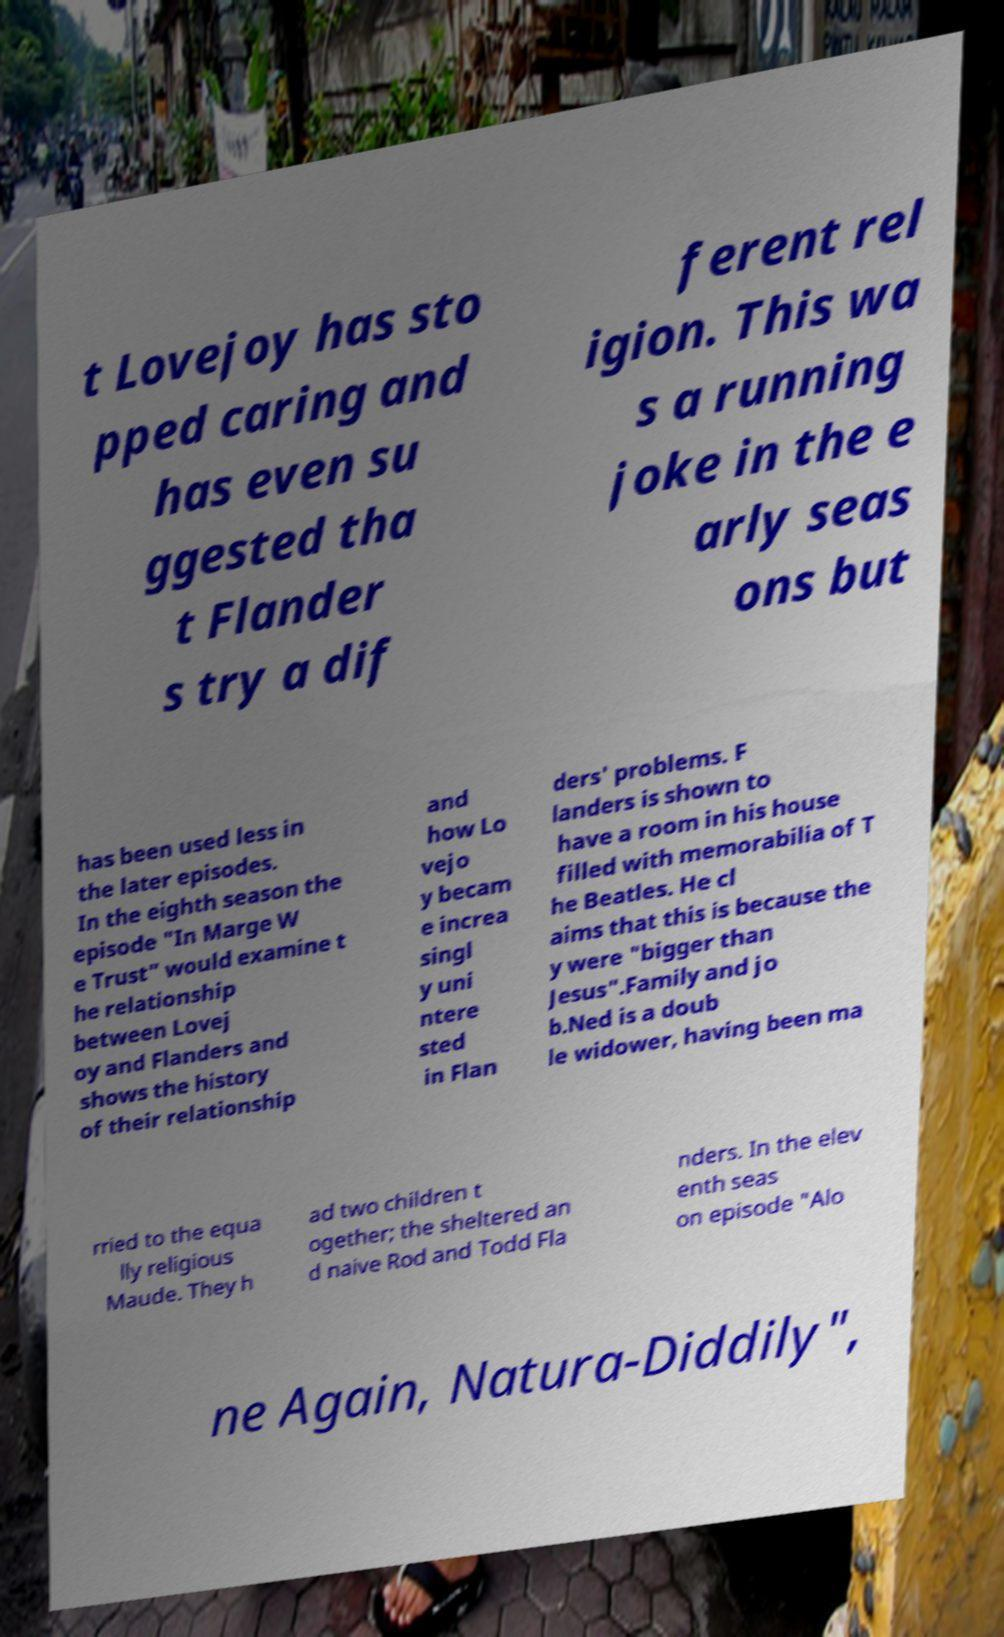Could you extract and type out the text from this image? t Lovejoy has sto pped caring and has even su ggested tha t Flander s try a dif ferent rel igion. This wa s a running joke in the e arly seas ons but has been used less in the later episodes. In the eighth season the episode "In Marge W e Trust" would examine t he relationship between Lovej oy and Flanders and shows the history of their relationship and how Lo vejo y becam e increa singl y uni ntere sted in Flan ders' problems. F landers is shown to have a room in his house filled with memorabilia of T he Beatles. He cl aims that this is because the y were "bigger than Jesus".Family and jo b.Ned is a doub le widower, having been ma rried to the equa lly religious Maude. They h ad two children t ogether; the sheltered an d naive Rod and Todd Fla nders. In the elev enth seas on episode "Alo ne Again, Natura-Diddily", 